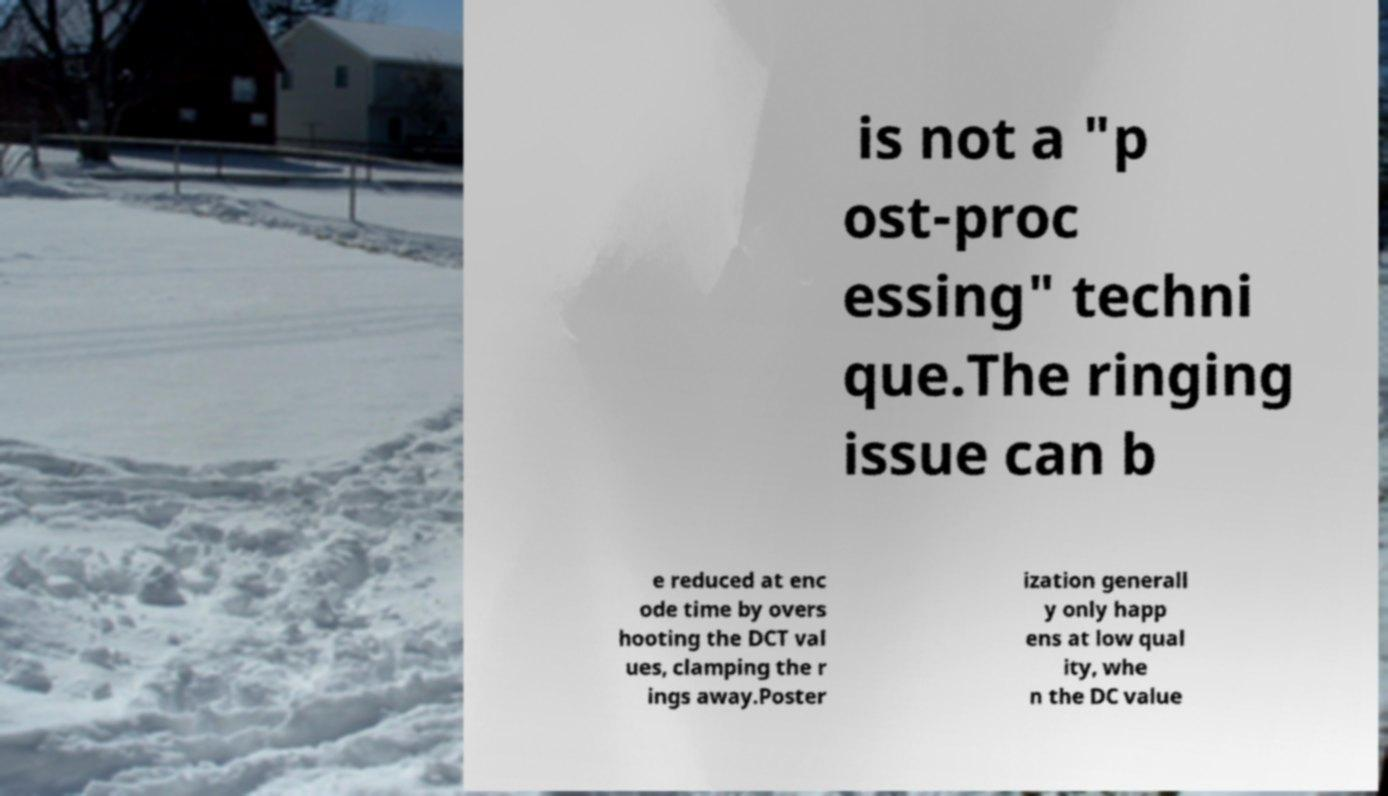I need the written content from this picture converted into text. Can you do that? is not a "p ost-proc essing" techni que.The ringing issue can b e reduced at enc ode time by overs hooting the DCT val ues, clamping the r ings away.Poster ization generall y only happ ens at low qual ity, whe n the DC value 